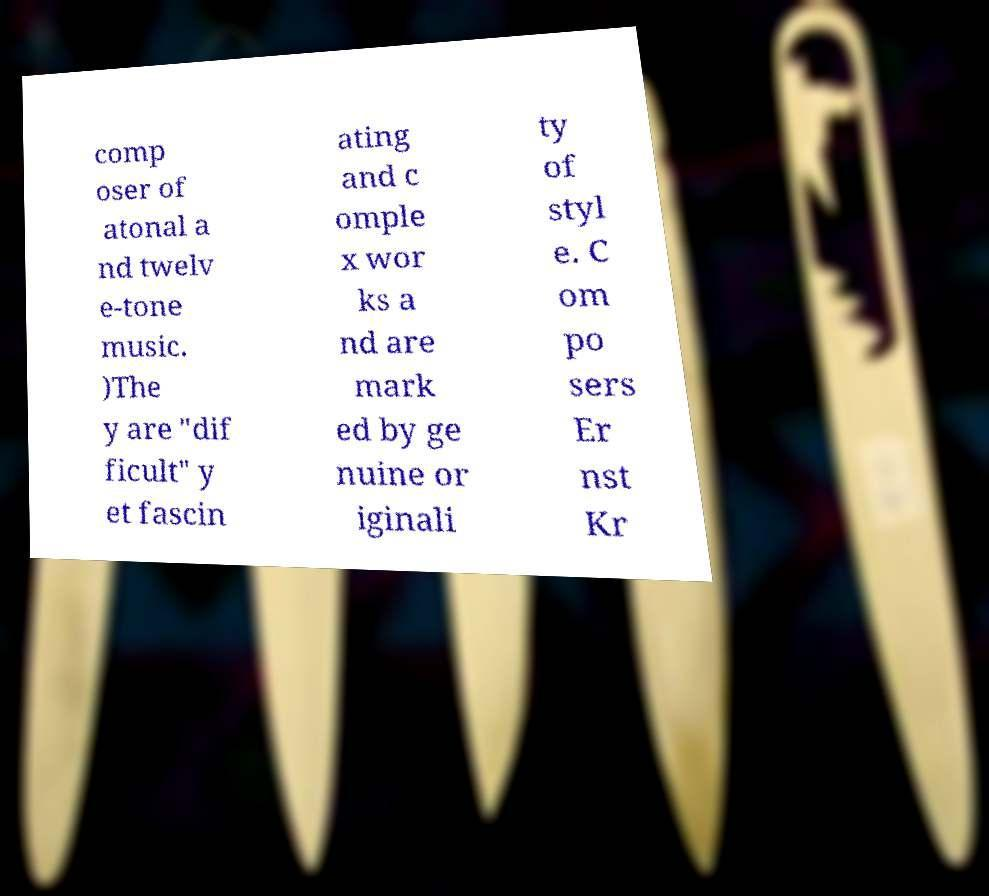Could you extract and type out the text from this image? comp oser of atonal a nd twelv e-tone music. )The y are "dif ficult" y et fascin ating and c omple x wor ks a nd are mark ed by ge nuine or iginali ty of styl e. C om po sers Er nst Kr 